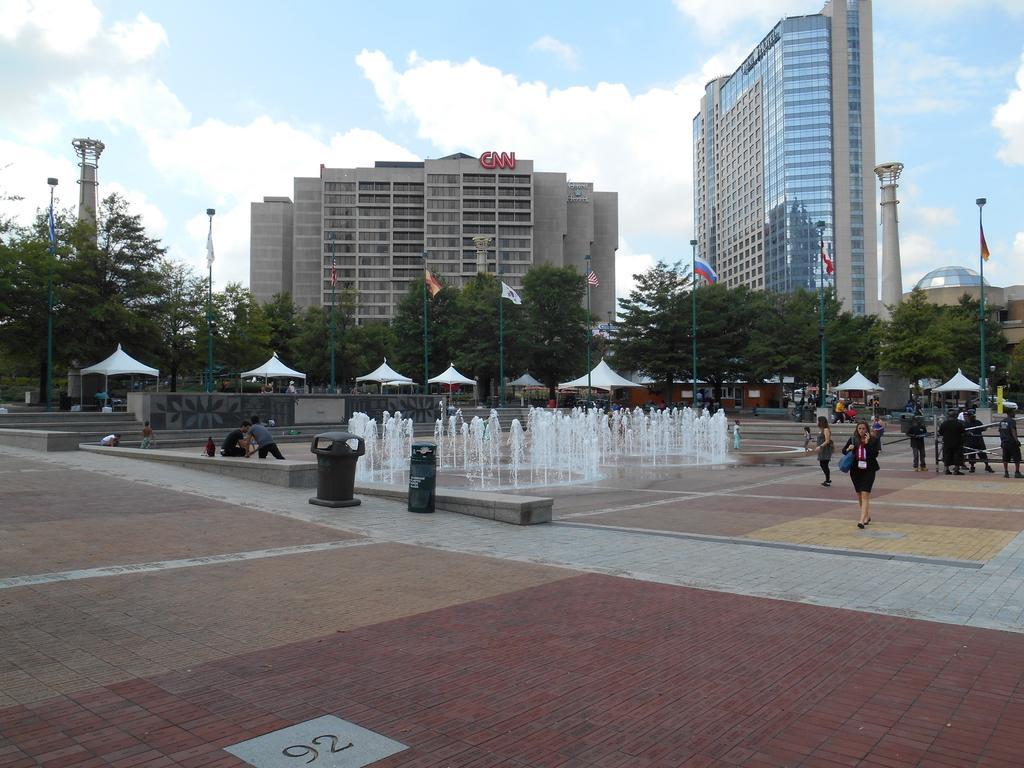Please provide a concise description of this image. In this picture there are people and we can see dust bins on the path, water fountain, flag poles, tents, trees and buildings. In the background of the image we can see the sky. 